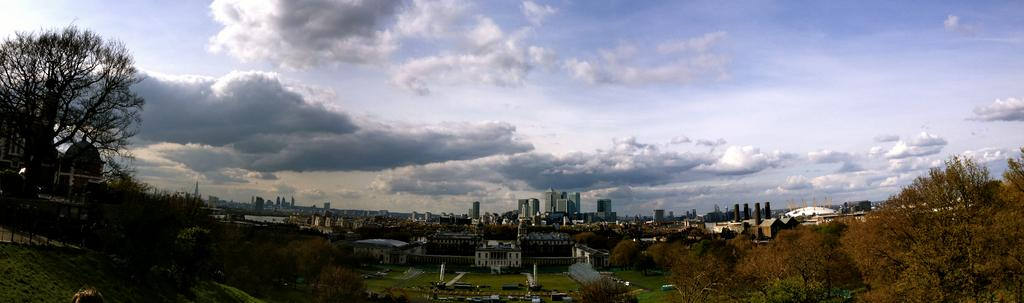What can be seen in the image that provides a beautiful view? There is a beautiful view in the image, but the specific subject is not mentioned in the facts. What type of structures can be seen in the image? There are buildings visible in the image. What type of vegetation is visible in the image? There are trees visible in the image. What can be seen in the sky in the image? There are clouds visible in the sky in the image. How many bikes are locked to the trees in the image? There are no bikes present in the image, so it is not possible to determine how many bikes might be locked to the trees. 